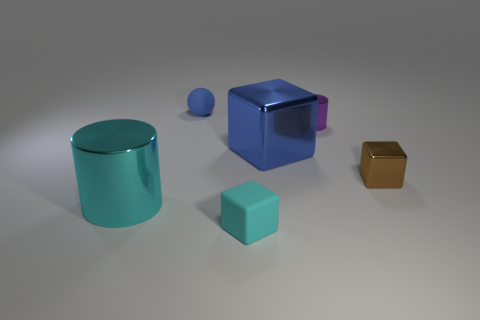There is a thing that is the same color as the matte cube; what is it made of?
Provide a succinct answer. Metal. How big is the cylinder that is in front of the cube on the right side of the large blue shiny cube?
Provide a succinct answer. Large. There is a tiny metallic object that is the same shape as the small cyan matte object; what color is it?
Your answer should be very brief. Brown. Is the cyan rubber thing the same size as the brown metallic object?
Your answer should be compact. Yes. Are there the same number of small matte objects right of the purple object and cubes?
Provide a short and direct response. No. Are there any blue balls on the right side of the metallic block that is behind the brown block?
Your response must be concise. No. There is a cyan thing that is right of the big object that is in front of the big thing behind the brown thing; how big is it?
Provide a short and direct response. Small. The blue thing that is in front of the cylinder that is behind the big metal cylinder is made of what material?
Your answer should be very brief. Metal. Is there another large blue metallic object of the same shape as the large blue metallic object?
Give a very brief answer. No. What is the shape of the brown thing?
Your answer should be compact. Cube. 